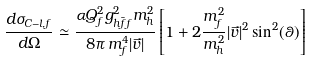<formula> <loc_0><loc_0><loc_500><loc_500>\frac { d \sigma _ { C - l , f } } { d \Omega } \simeq \frac { \alpha Q _ { f } ^ { 2 } g ^ { 2 } _ { h \bar { f } f } m _ { h } ^ { 2 } } { 8 \pi \, m _ { f } ^ { 4 } | \vec { v } | } \left [ 1 + 2 \frac { m _ { f } ^ { 2 } } { m _ { h } ^ { 2 } } | \vec { v } | ^ { 2 } \sin ^ { 2 } ( \theta ) \right ]</formula> 